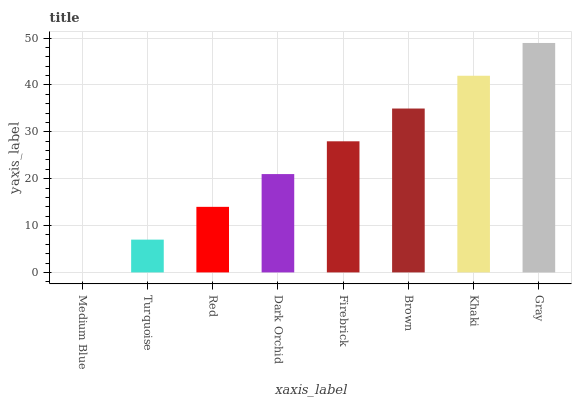Is Medium Blue the minimum?
Answer yes or no. Yes. Is Gray the maximum?
Answer yes or no. Yes. Is Turquoise the minimum?
Answer yes or no. No. Is Turquoise the maximum?
Answer yes or no. No. Is Turquoise greater than Medium Blue?
Answer yes or no. Yes. Is Medium Blue less than Turquoise?
Answer yes or no. Yes. Is Medium Blue greater than Turquoise?
Answer yes or no. No. Is Turquoise less than Medium Blue?
Answer yes or no. No. Is Firebrick the high median?
Answer yes or no. Yes. Is Dark Orchid the low median?
Answer yes or no. Yes. Is Gray the high median?
Answer yes or no. No. Is Turquoise the low median?
Answer yes or no. No. 